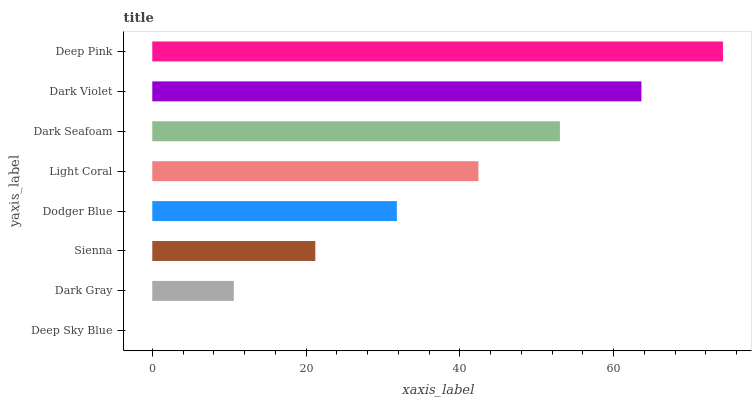Is Deep Sky Blue the minimum?
Answer yes or no. Yes. Is Deep Pink the maximum?
Answer yes or no. Yes. Is Dark Gray the minimum?
Answer yes or no. No. Is Dark Gray the maximum?
Answer yes or no. No. Is Dark Gray greater than Deep Sky Blue?
Answer yes or no. Yes. Is Deep Sky Blue less than Dark Gray?
Answer yes or no. Yes. Is Deep Sky Blue greater than Dark Gray?
Answer yes or no. No. Is Dark Gray less than Deep Sky Blue?
Answer yes or no. No. Is Light Coral the high median?
Answer yes or no. Yes. Is Dodger Blue the low median?
Answer yes or no. Yes. Is Dark Violet the high median?
Answer yes or no. No. Is Dark Violet the low median?
Answer yes or no. No. 